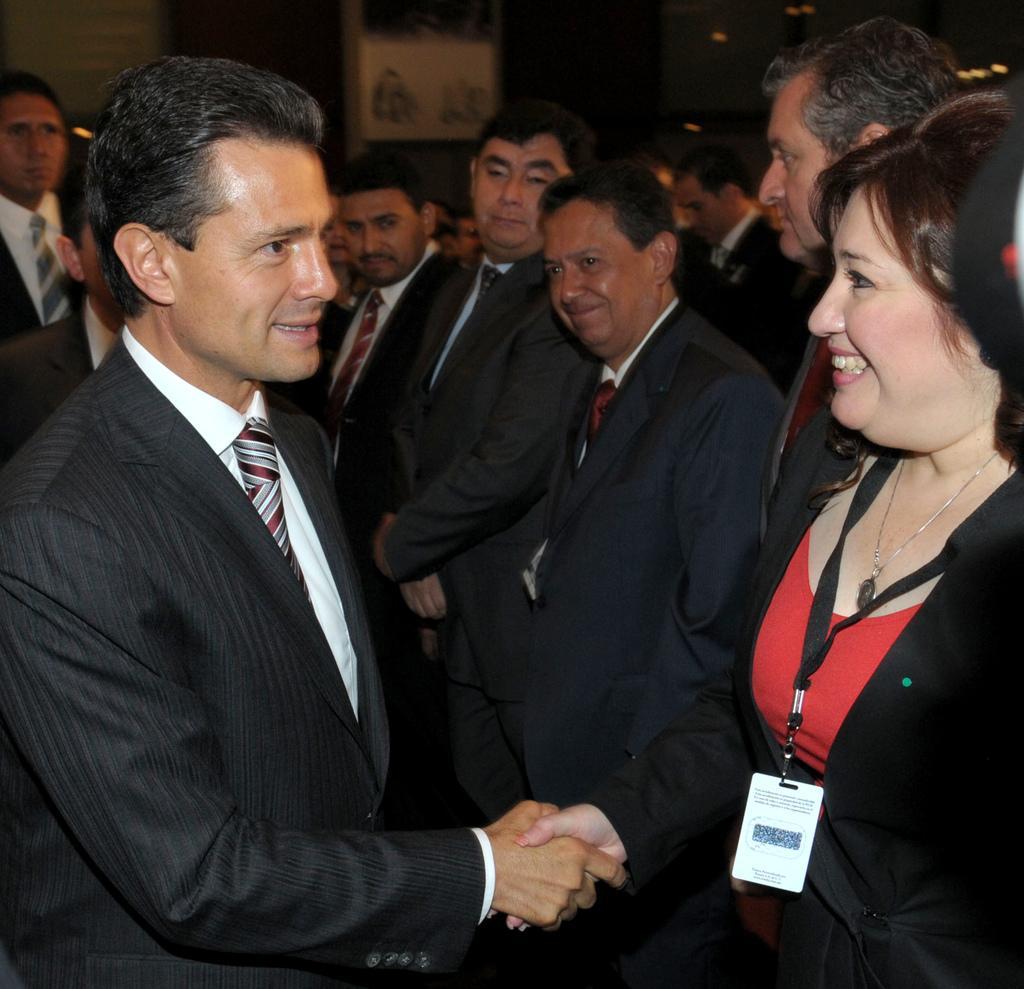Can you describe this image briefly? In this picture I can see few people are standing and I can see a woman is wearing a ID card and she is shaking hand with a man. 